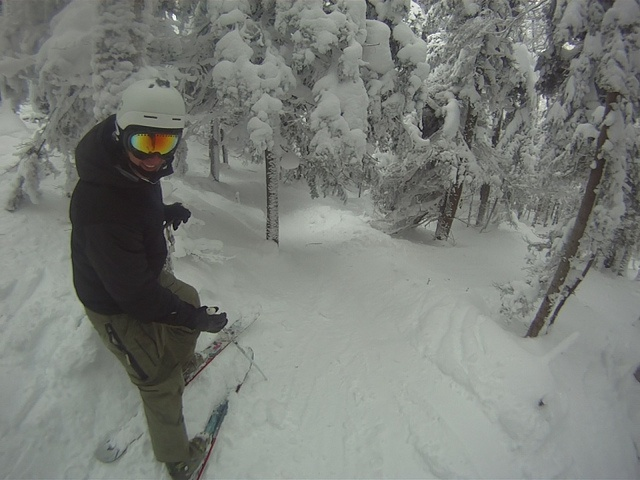Describe the objects in this image and their specific colors. I can see people in gray and black tones and skis in gray tones in this image. 